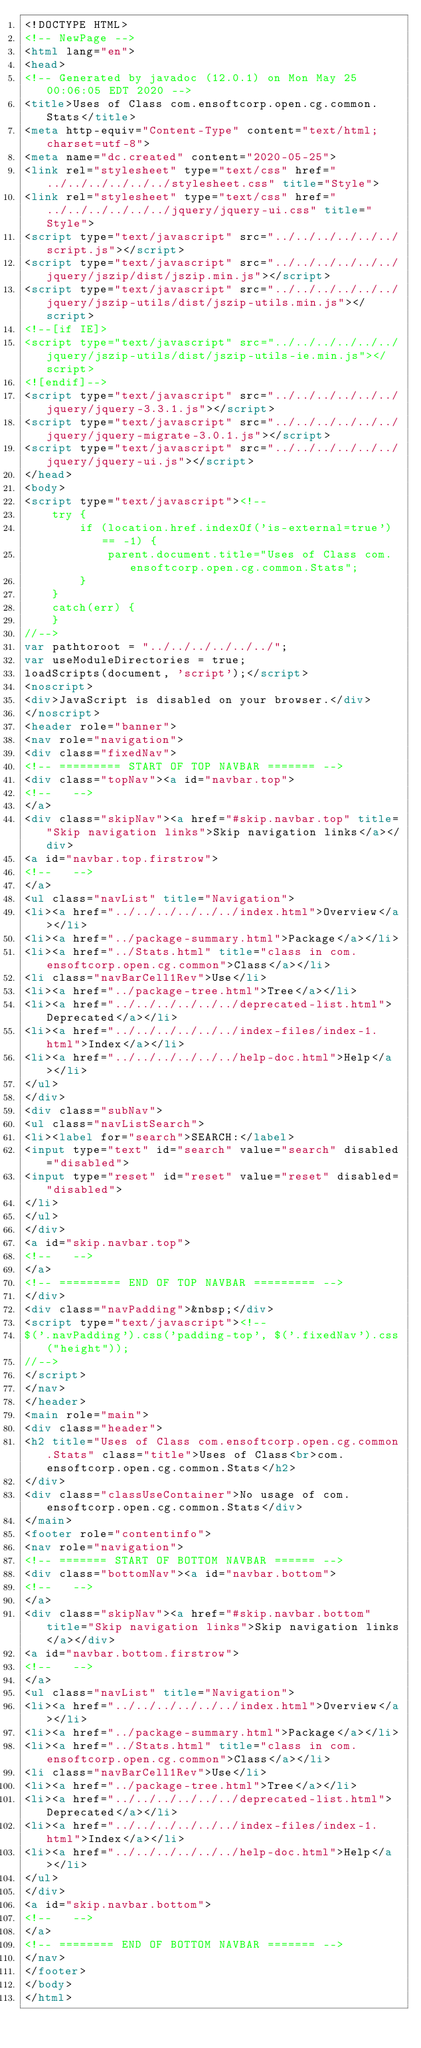Convert code to text. <code><loc_0><loc_0><loc_500><loc_500><_HTML_><!DOCTYPE HTML>
<!-- NewPage -->
<html lang="en">
<head>
<!-- Generated by javadoc (12.0.1) on Mon May 25 00:06:05 EDT 2020 -->
<title>Uses of Class com.ensoftcorp.open.cg.common.Stats</title>
<meta http-equiv="Content-Type" content="text/html; charset=utf-8">
<meta name="dc.created" content="2020-05-25">
<link rel="stylesheet" type="text/css" href="../../../../../../stylesheet.css" title="Style">
<link rel="stylesheet" type="text/css" href="../../../../../../jquery/jquery-ui.css" title="Style">
<script type="text/javascript" src="../../../../../../script.js"></script>
<script type="text/javascript" src="../../../../../../jquery/jszip/dist/jszip.min.js"></script>
<script type="text/javascript" src="../../../../../../jquery/jszip-utils/dist/jszip-utils.min.js"></script>
<!--[if IE]>
<script type="text/javascript" src="../../../../../../jquery/jszip-utils/dist/jszip-utils-ie.min.js"></script>
<![endif]-->
<script type="text/javascript" src="../../../../../../jquery/jquery-3.3.1.js"></script>
<script type="text/javascript" src="../../../../../../jquery/jquery-migrate-3.0.1.js"></script>
<script type="text/javascript" src="../../../../../../jquery/jquery-ui.js"></script>
</head>
<body>
<script type="text/javascript"><!--
    try {
        if (location.href.indexOf('is-external=true') == -1) {
            parent.document.title="Uses of Class com.ensoftcorp.open.cg.common.Stats";
        }
    }
    catch(err) {
    }
//-->
var pathtoroot = "../../../../../../";
var useModuleDirectories = true;
loadScripts(document, 'script');</script>
<noscript>
<div>JavaScript is disabled on your browser.</div>
</noscript>
<header role="banner">
<nav role="navigation">
<div class="fixedNav">
<!-- ========= START OF TOP NAVBAR ======= -->
<div class="topNav"><a id="navbar.top">
<!--   -->
</a>
<div class="skipNav"><a href="#skip.navbar.top" title="Skip navigation links">Skip navigation links</a></div>
<a id="navbar.top.firstrow">
<!--   -->
</a>
<ul class="navList" title="Navigation">
<li><a href="../../../../../../index.html">Overview</a></li>
<li><a href="../package-summary.html">Package</a></li>
<li><a href="../Stats.html" title="class in com.ensoftcorp.open.cg.common">Class</a></li>
<li class="navBarCell1Rev">Use</li>
<li><a href="../package-tree.html">Tree</a></li>
<li><a href="../../../../../../deprecated-list.html">Deprecated</a></li>
<li><a href="../../../../../../index-files/index-1.html">Index</a></li>
<li><a href="../../../../../../help-doc.html">Help</a></li>
</ul>
</div>
<div class="subNav">
<ul class="navListSearch">
<li><label for="search">SEARCH:</label>
<input type="text" id="search" value="search" disabled="disabled">
<input type="reset" id="reset" value="reset" disabled="disabled">
</li>
</ul>
</div>
<a id="skip.navbar.top">
<!--   -->
</a>
<!-- ========= END OF TOP NAVBAR ========= -->
</div>
<div class="navPadding">&nbsp;</div>
<script type="text/javascript"><!--
$('.navPadding').css('padding-top', $('.fixedNav').css("height"));
//-->
</script>
</nav>
</header>
<main role="main">
<div class="header">
<h2 title="Uses of Class com.ensoftcorp.open.cg.common.Stats" class="title">Uses of Class<br>com.ensoftcorp.open.cg.common.Stats</h2>
</div>
<div class="classUseContainer">No usage of com.ensoftcorp.open.cg.common.Stats</div>
</main>
<footer role="contentinfo">
<nav role="navigation">
<!-- ======= START OF BOTTOM NAVBAR ====== -->
<div class="bottomNav"><a id="navbar.bottom">
<!--   -->
</a>
<div class="skipNav"><a href="#skip.navbar.bottom" title="Skip navigation links">Skip navigation links</a></div>
<a id="navbar.bottom.firstrow">
<!--   -->
</a>
<ul class="navList" title="Navigation">
<li><a href="../../../../../../index.html">Overview</a></li>
<li><a href="../package-summary.html">Package</a></li>
<li><a href="../Stats.html" title="class in com.ensoftcorp.open.cg.common">Class</a></li>
<li class="navBarCell1Rev">Use</li>
<li><a href="../package-tree.html">Tree</a></li>
<li><a href="../../../../../../deprecated-list.html">Deprecated</a></li>
<li><a href="../../../../../../index-files/index-1.html">Index</a></li>
<li><a href="../../../../../../help-doc.html">Help</a></li>
</ul>
</div>
<a id="skip.navbar.bottom">
<!--   -->
</a>
<!-- ======== END OF BOTTOM NAVBAR ======= -->
</nav>
</footer>
</body>
</html>
</code> 